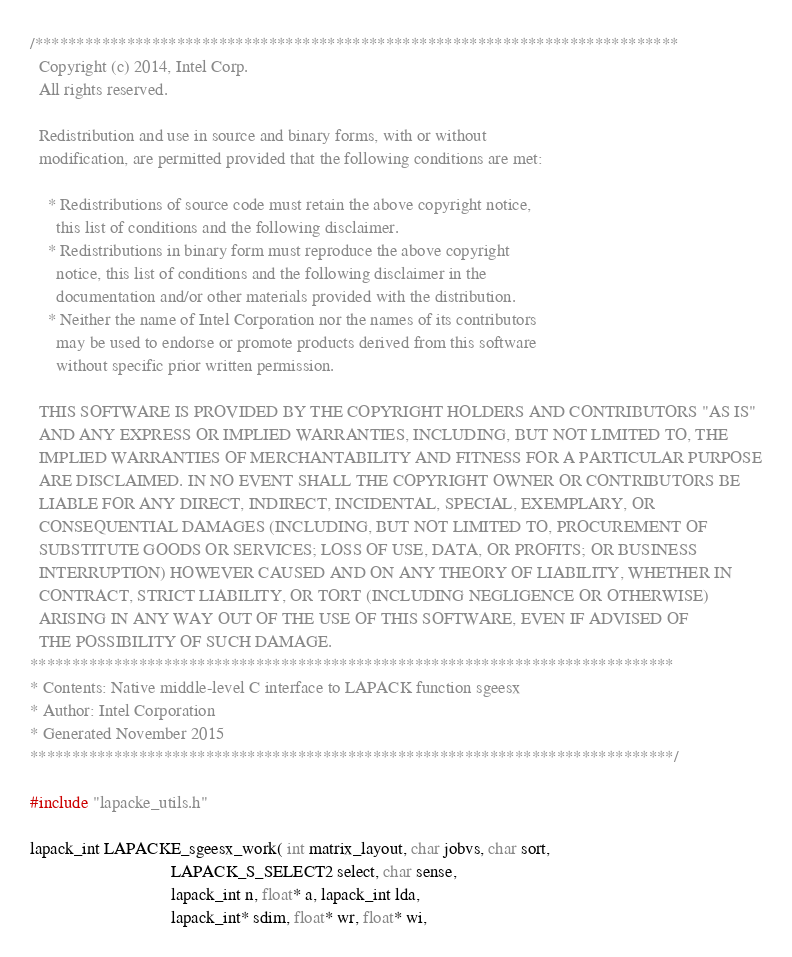Convert code to text. <code><loc_0><loc_0><loc_500><loc_500><_C_>/*****************************************************************************
  Copyright (c) 2014, Intel Corp.
  All rights reserved.

  Redistribution and use in source and binary forms, with or without
  modification, are permitted provided that the following conditions are met:

    * Redistributions of source code must retain the above copyright notice,
      this list of conditions and the following disclaimer.
    * Redistributions in binary form must reproduce the above copyright
      notice, this list of conditions and the following disclaimer in the
      documentation and/or other materials provided with the distribution.
    * Neither the name of Intel Corporation nor the names of its contributors
      may be used to endorse or promote products derived from this software
      without specific prior written permission.

  THIS SOFTWARE IS PROVIDED BY THE COPYRIGHT HOLDERS AND CONTRIBUTORS "AS IS"
  AND ANY EXPRESS OR IMPLIED WARRANTIES, INCLUDING, BUT NOT LIMITED TO, THE
  IMPLIED WARRANTIES OF MERCHANTABILITY AND FITNESS FOR A PARTICULAR PURPOSE
  ARE DISCLAIMED. IN NO EVENT SHALL THE COPYRIGHT OWNER OR CONTRIBUTORS BE
  LIABLE FOR ANY DIRECT, INDIRECT, INCIDENTAL, SPECIAL, EXEMPLARY, OR
  CONSEQUENTIAL DAMAGES (INCLUDING, BUT NOT LIMITED TO, PROCUREMENT OF
  SUBSTITUTE GOODS OR SERVICES; LOSS OF USE, DATA, OR PROFITS; OR BUSINESS
  INTERRUPTION) HOWEVER CAUSED AND ON ANY THEORY OF LIABILITY, WHETHER IN
  CONTRACT, STRICT LIABILITY, OR TORT (INCLUDING NEGLIGENCE OR OTHERWISE)
  ARISING IN ANY WAY OUT OF THE USE OF THIS SOFTWARE, EVEN IF ADVISED OF
  THE POSSIBILITY OF SUCH DAMAGE.
*****************************************************************************
* Contents: Native middle-level C interface to LAPACK function sgeesx
* Author: Intel Corporation
* Generated November 2015
*****************************************************************************/

#include "lapacke_utils.h"

lapack_int LAPACKE_sgeesx_work( int matrix_layout, char jobvs, char sort,
                                LAPACK_S_SELECT2 select, char sense,
                                lapack_int n, float* a, lapack_int lda,
                                lapack_int* sdim, float* wr, float* wi,</code> 